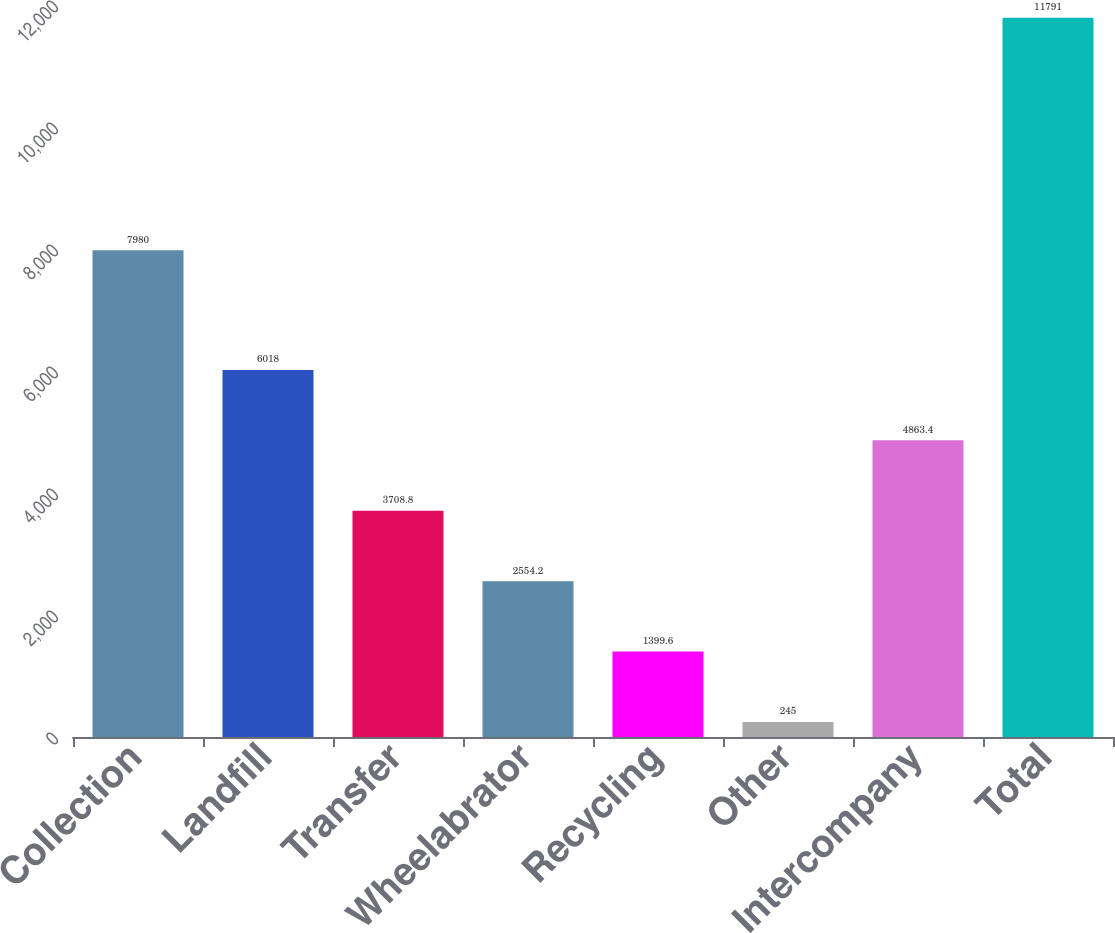Convert chart to OTSL. <chart><loc_0><loc_0><loc_500><loc_500><bar_chart><fcel>Collection<fcel>Landfill<fcel>Transfer<fcel>Wheelabrator<fcel>Recycling<fcel>Other<fcel>Intercompany<fcel>Total<nl><fcel>7980<fcel>6018<fcel>3708.8<fcel>2554.2<fcel>1399.6<fcel>245<fcel>4863.4<fcel>11791<nl></chart> 